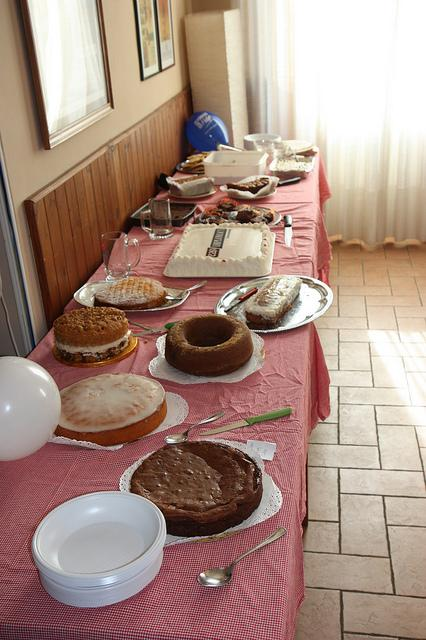How many cakes needed to cool down before adding a creamy glaze to it?

Choices:
A) two
B) none
C) three
D) one three 